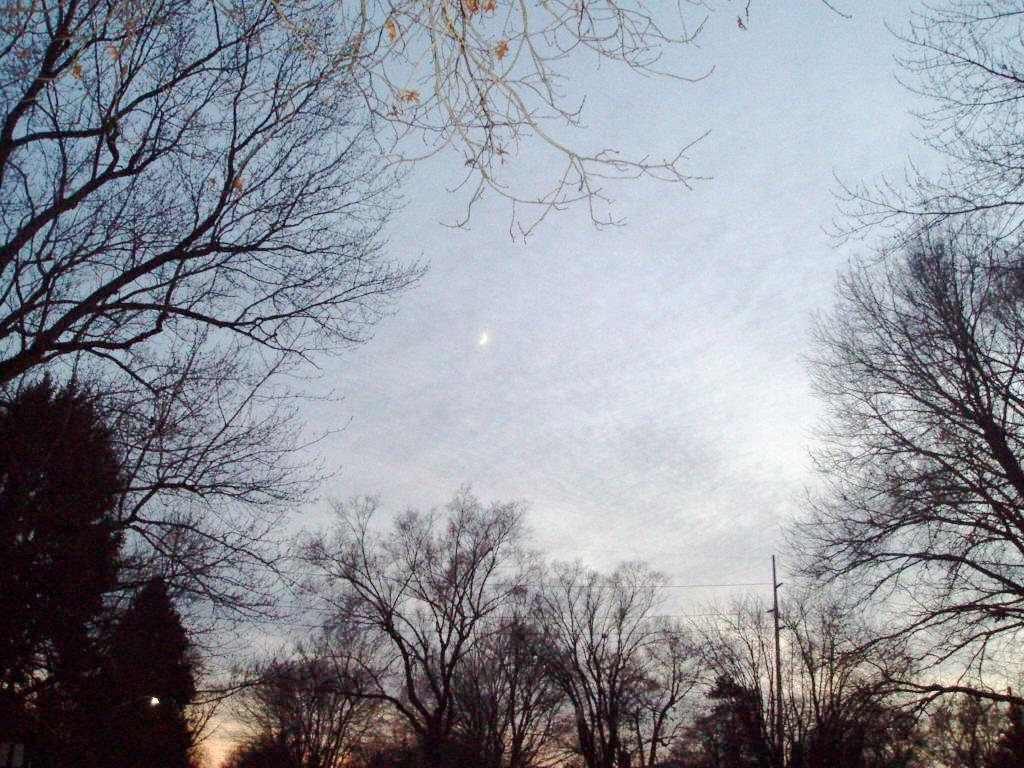What type of vegetation can be seen in the image? There are trees in the image. What part of the natural environment is visible in the image? The sky is visible in the image. What celestial body can be seen in the sky? The moon is present in the image. What type of egg is being cooked by the mom in the image? There is no egg or mom present in the image; it only features trees, the sky, and the moon. 